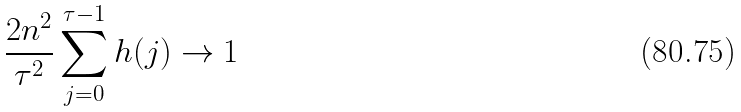Convert formula to latex. <formula><loc_0><loc_0><loc_500><loc_500>\frac { 2 n ^ { 2 } } { \tau ^ { 2 } } \sum _ { j = 0 } ^ { \tau - 1 } h ( j ) \to 1</formula> 